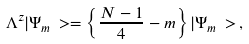<formula> <loc_0><loc_0><loc_500><loc_500>\Lambda ^ { z } | \Psi _ { m } \, > = \left \{ \frac { N - 1 } { 4 } - m \right \} | \Psi _ { m } \, > \, ,</formula> 